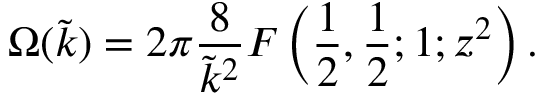Convert formula to latex. <formula><loc_0><loc_0><loc_500><loc_500>\Omega ( \tilde { k } ) = 2 \pi \frac { 8 } { \tilde { k } ^ { 2 } } F \left ( \frac { 1 } { 2 } , \frac { 1 } { 2 } ; 1 ; z ^ { 2 } \right ) .</formula> 